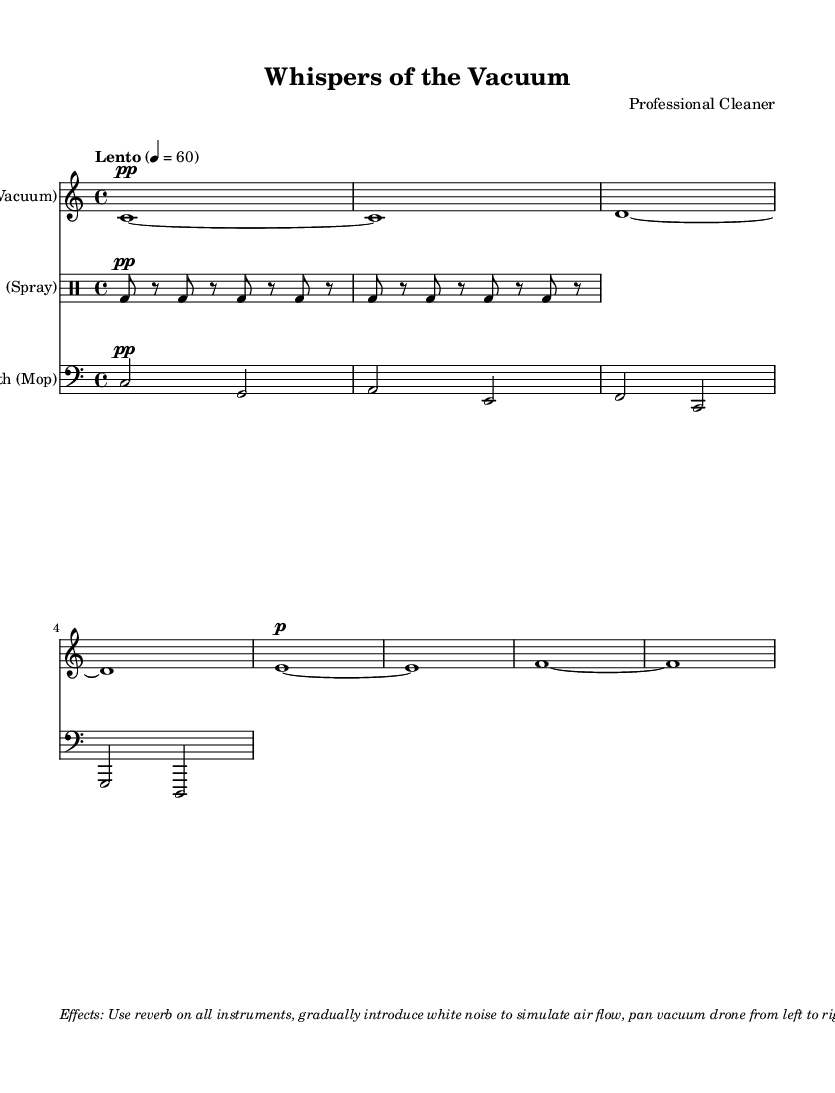What key signature is this music in? The key signature is C major, which is indicated at the beginning of the global section with the command " \key c \major ". The absence of any sharps or flats confirms it is in C major.
Answer: C major What is the time signature of this piece? The time signature is 4/4, indicated by the command " \time 4/4 " in the global section. This means there are four beats per measure.
Answer: 4/4 What is the tempo marking of the composition? The tempo marking is "Lento," indicated by the command " \tempo "Lento" 4 = 60 ", suggesting a slow pace at 60 beats per minute.
Answer: Lento How many distinct instruments are used in the sheet music? There are three distinct instruments: a synthesizer representing the vacuum, a percussion instrument representing a spray, and another synthesizer representing the mop. They are all specified in the score section.
Answer: Three What dynamic marking is noted for the synthesizer? The dynamic marking for the synthesizer is "pp," which stands for pianissimo, indicating that the music should be played very softly. This marking is present on the first note of the synthesizer staff.
Answer: pp What is the effect specified for all instruments? The specified effect for all instruments is reverb, as noted in the markup at the end. This will create a more atmospheric sound for the entire piece.
Answer: Reverb What kind of sound does the percussion part imitate? The percussion part imitates the sound of a vacuum, using the bass drum notation in the drummode section. This choice reflects the context of cleaning tools and their rhythmic sounds.
Answer: Vacuum 